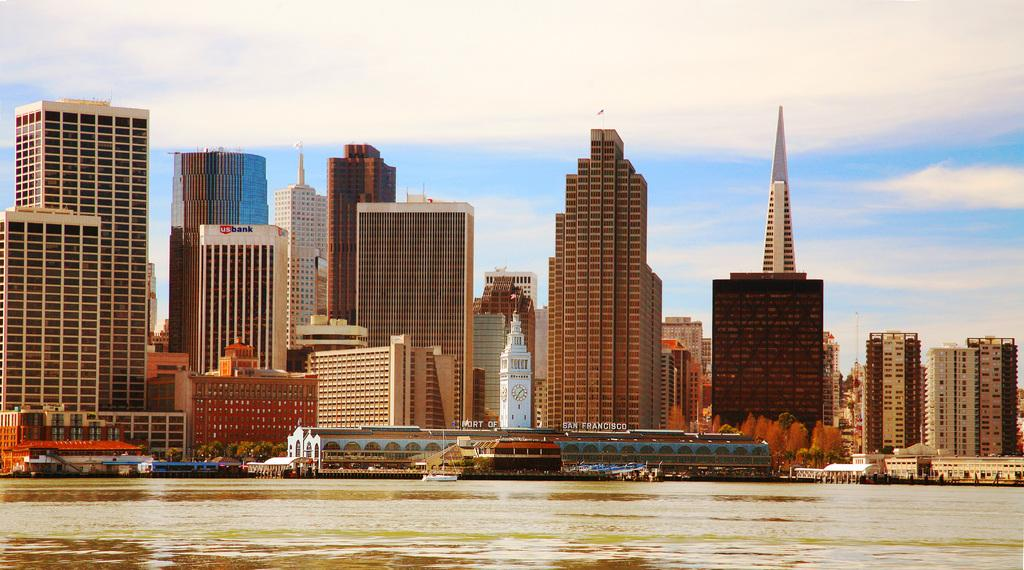What type of structures can be seen in the image? There are buildings in the image. What other natural elements are present in the image? There are trees in the image. What time-related object is visible in the image? There is a clock in the image. What mode of transportation can be seen in the image? There are boats on water in the image. What else can be found in the image besides the mentioned elements? There are objects in the image. What can be seen in the background of the image? The sky is visible in the background of the image, and clouds are present in the sky. Where is the band performing in the image? There is no band present in the image. Is there a jail visible in the image? There is no jail visible in the image. 